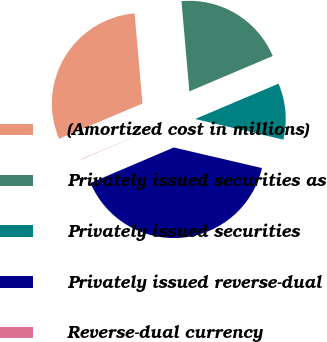Convert chart. <chart><loc_0><loc_0><loc_500><loc_500><pie_chart><fcel>(Amortized cost in millions)<fcel>Privately issued securities as<fcel>Privately issued securities<fcel>Privately issued reverse-dual<fcel>Reverse-dual currency<nl><fcel>29.97%<fcel>20.0%<fcel>10.03%<fcel>39.94%<fcel>0.06%<nl></chart> 